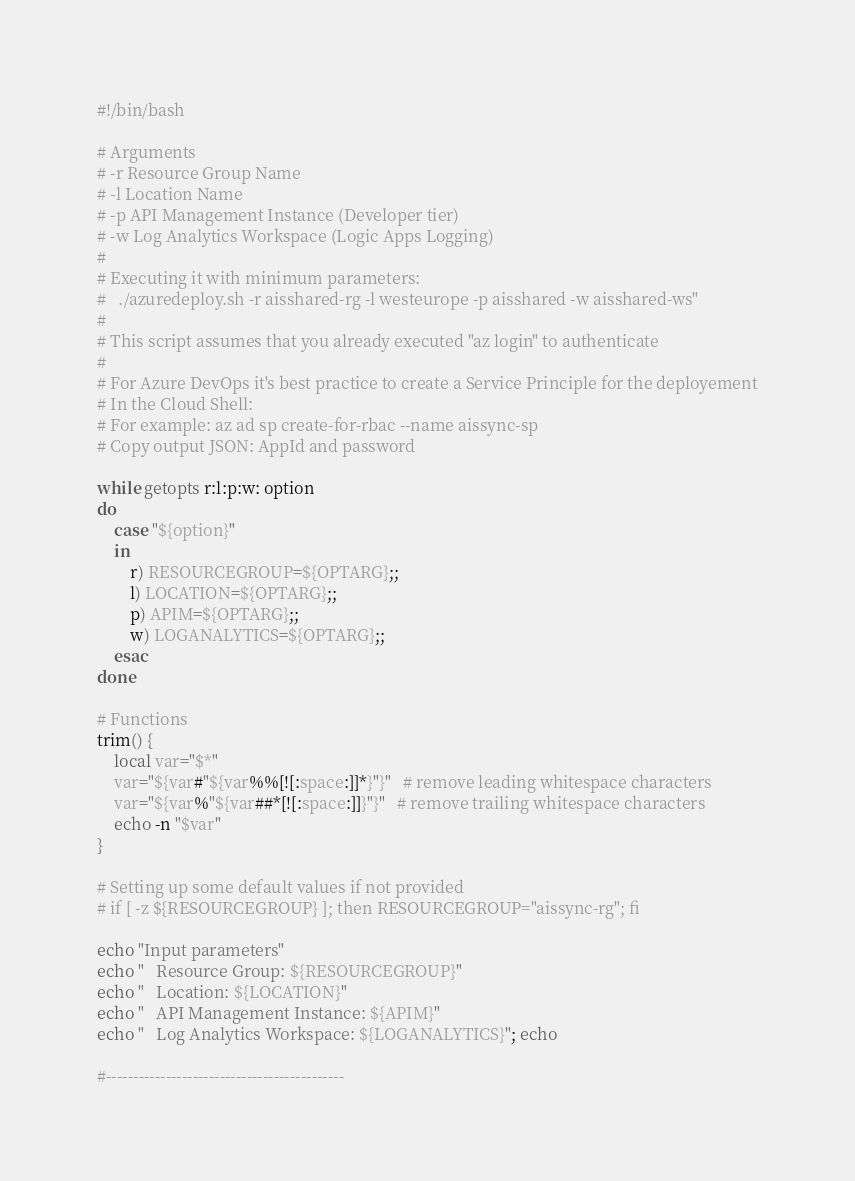Convert code to text. <code><loc_0><loc_0><loc_500><loc_500><_Bash_>#!/bin/bash

# Arguments
# -r Resource Group Name
# -l Location Name
# -p API Management Instance (Developer tier)
# -w Log Analytics Workspace (Logic Apps Logging)
# 
# Executing it with minimum parameters:
#   ./azuredeploy.sh -r aisshared-rg -l westeurope -p aisshared -w aisshared-ws"
#
# This script assumes that you already executed "az login" to authenticate 
#
# For Azure DevOps it's best practice to create a Service Principle for the deployement
# In the Cloud Shell:
# For example: az ad sp create-for-rbac --name aissync-sp
# Copy output JSON: AppId and password

while getopts r:l:p:w: option
do
	case "${option}"
	in
		r) RESOURCEGROUP=${OPTARG};;
		l) LOCATION=${OPTARG};;
		p) APIM=${OPTARG};;
		w) LOGANALYTICS=${OPTARG};;	
	esac
done

# Functions
trim() {
    local var="$*"
    var="${var#"${var%%[![:space:]]*}"}"   # remove leading whitespace characters
    var="${var%"${var##*[![:space:]]}"}"   # remove trailing whitespace characters
    echo -n "$var"
}

# Setting up some default values if not provided
# if [ -z ${RESOURCEGROUP} ]; then RESOURCEGROUP="aissync-rg"; fi 

echo "Input parameters"
echo "   Resource Group: ${RESOURCEGROUP}"
echo "   Location: ${LOCATION}"
echo "   API Management Instance: ${APIM}"
echo "   Log Analytics Workspace: ${LOGANALYTICS}"; echo

#--------------------------------------------</code> 